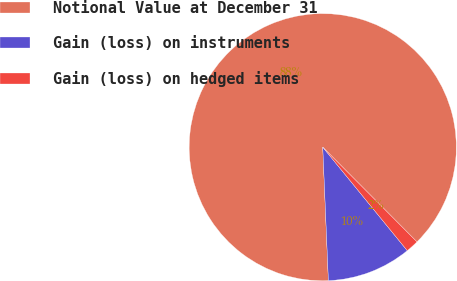Convert chart. <chart><loc_0><loc_0><loc_500><loc_500><pie_chart><fcel>Notional Value at December 31<fcel>Gain (loss) on instruments<fcel>Gain (loss) on hedged items<nl><fcel>88.22%<fcel>10.23%<fcel>1.56%<nl></chart> 